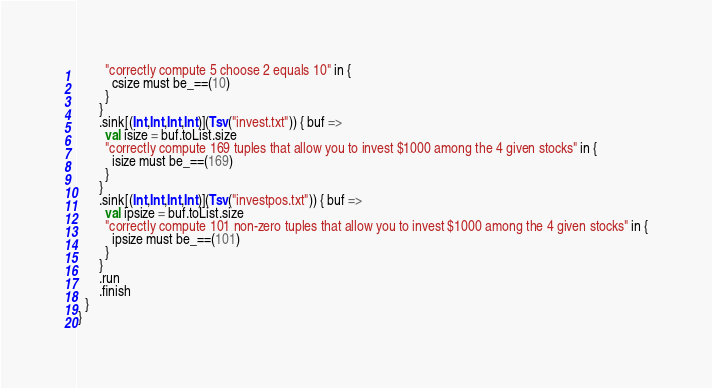Convert code to text. <code><loc_0><loc_0><loc_500><loc_500><_Scala_>        "correctly compute 5 choose 2 equals 10" in {
          csize must be_==(10)
        }
      }
      .sink[(Int,Int,Int,Int)](Tsv("invest.txt")) { buf =>
        val isize = buf.toList.size
        "correctly compute 169 tuples that allow you to invest $1000 among the 4 given stocks" in {
          isize must be_==(169)
        }
      }
      .sink[(Int,Int,Int,Int)](Tsv("investpos.txt")) { buf =>
        val ipsize = buf.toList.size
        "correctly compute 101 non-zero tuples that allow you to invest $1000 among the 4 given stocks" in {
          ipsize must be_==(101)
        }
      }
      .run
      .finish
  }
}
</code> 